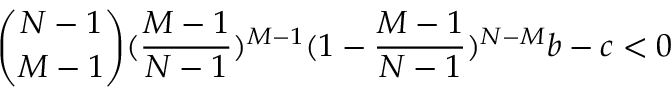<formula> <loc_0><loc_0><loc_500><loc_500>\binom { N - 1 } { M - 1 } ( \frac { M - 1 } { N - 1 } ) ^ { M - 1 } ( 1 - \frac { M - 1 } { N - 1 } ) ^ { N - M } b - c < 0</formula> 